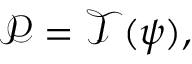Convert formula to latex. <formula><loc_0><loc_0><loc_500><loc_500>\mathcal { P } = \mathcal { T } ( \psi ) ,</formula> 